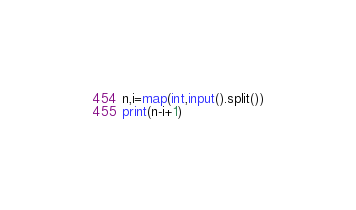<code> <loc_0><loc_0><loc_500><loc_500><_Python_>n,i=map(int,input().split())
print(n-i+1)
</code> 